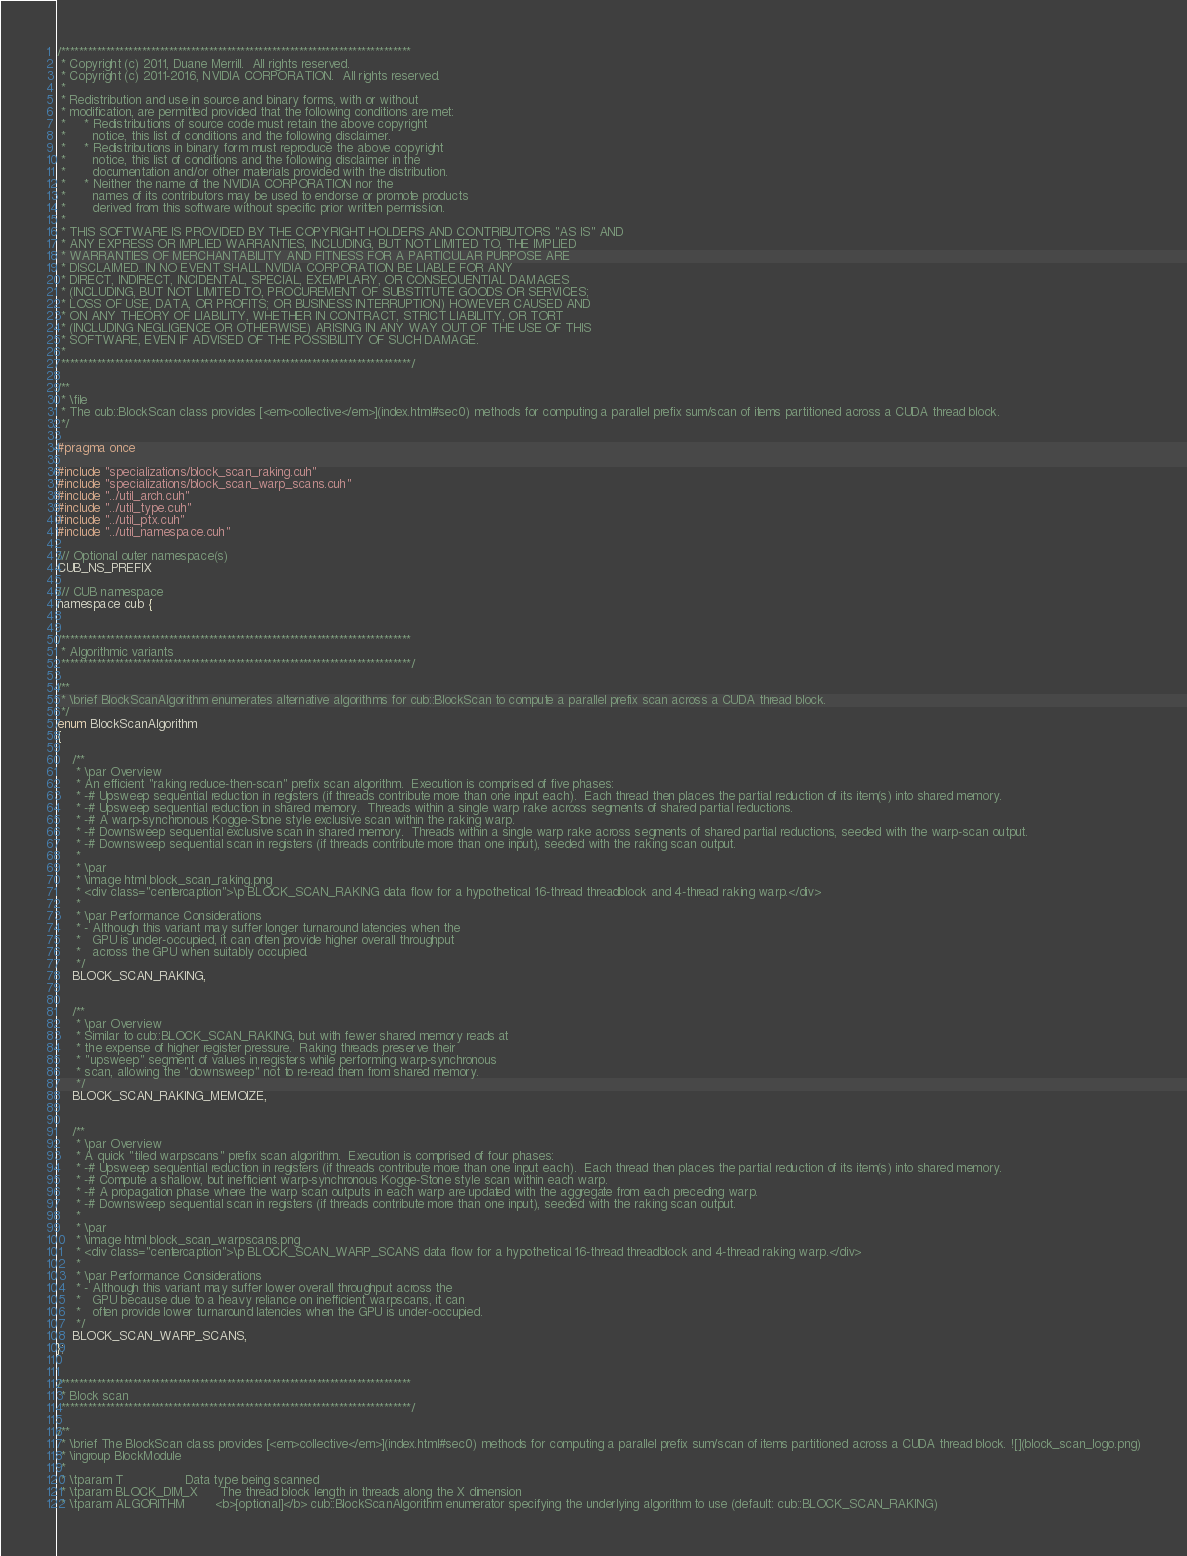Convert code to text. <code><loc_0><loc_0><loc_500><loc_500><_Cuda_>/******************************************************************************
 * Copyright (c) 2011, Duane Merrill.  All rights reserved.
 * Copyright (c) 2011-2016, NVIDIA CORPORATION.  All rights reserved.
 *
 * Redistribution and use in source and binary forms, with or without
 * modification, are permitted provided that the following conditions are met:
 *     * Redistributions of source code must retain the above copyright
 *       notice, this list of conditions and the following disclaimer.
 *     * Redistributions in binary form must reproduce the above copyright
 *       notice, this list of conditions and the following disclaimer in the
 *       documentation and/or other materials provided with the distribution.
 *     * Neither the name of the NVIDIA CORPORATION nor the
 *       names of its contributors may be used to endorse or promote products
 *       derived from this software without specific prior written permission.
 *
 * THIS SOFTWARE IS PROVIDED BY THE COPYRIGHT HOLDERS AND CONTRIBUTORS "AS IS" AND
 * ANY EXPRESS OR IMPLIED WARRANTIES, INCLUDING, BUT NOT LIMITED TO, THE IMPLIED
 * WARRANTIES OF MERCHANTABILITY AND FITNESS FOR A PARTICULAR PURPOSE ARE
 * DISCLAIMED. IN NO EVENT SHALL NVIDIA CORPORATION BE LIABLE FOR ANY
 * DIRECT, INDIRECT, INCIDENTAL, SPECIAL, EXEMPLARY, OR CONSEQUENTIAL DAMAGES
 * (INCLUDING, BUT NOT LIMITED TO, PROCUREMENT OF SUBSTITUTE GOODS OR SERVICES;
 * LOSS OF USE, DATA, OR PROFITS; OR BUSINESS INTERRUPTION) HOWEVER CAUSED AND
 * ON ANY THEORY OF LIABILITY, WHETHER IN CONTRACT, STRICT LIABILITY, OR TORT
 * (INCLUDING NEGLIGENCE OR OTHERWISE) ARISING IN ANY WAY OUT OF THE USE OF THIS
 * SOFTWARE, EVEN IF ADVISED OF THE POSSIBILITY OF SUCH DAMAGE.
 *
 ******************************************************************************/

/**
 * \file
 * The cub::BlockScan class provides [<em>collective</em>](index.html#sec0) methods for computing a parallel prefix sum/scan of items partitioned across a CUDA thread block.
 */

#pragma once

#include "specializations/block_scan_raking.cuh"
#include "specializations/block_scan_warp_scans.cuh"
#include "../util_arch.cuh"
#include "../util_type.cuh"
#include "../util_ptx.cuh"
#include "../util_namespace.cuh"

/// Optional outer namespace(s)
CUB_NS_PREFIX

/// CUB namespace
namespace cub {


/******************************************************************************
 * Algorithmic variants
 ******************************************************************************/

/**
 * \brief BlockScanAlgorithm enumerates alternative algorithms for cub::BlockScan to compute a parallel prefix scan across a CUDA thread block.
 */
enum BlockScanAlgorithm
{

    /**
     * \par Overview
     * An efficient "raking reduce-then-scan" prefix scan algorithm.  Execution is comprised of five phases:
     * -# Upsweep sequential reduction in registers (if threads contribute more than one input each).  Each thread then places the partial reduction of its item(s) into shared memory.
     * -# Upsweep sequential reduction in shared memory.  Threads within a single warp rake across segments of shared partial reductions.
     * -# A warp-synchronous Kogge-Stone style exclusive scan within the raking warp.
     * -# Downsweep sequential exclusive scan in shared memory.  Threads within a single warp rake across segments of shared partial reductions, seeded with the warp-scan output.
     * -# Downsweep sequential scan in registers (if threads contribute more than one input), seeded with the raking scan output.
     *
     * \par
     * \image html block_scan_raking.png
     * <div class="centercaption">\p BLOCK_SCAN_RAKING data flow for a hypothetical 16-thread threadblock and 4-thread raking warp.</div>
     *
     * \par Performance Considerations
     * - Although this variant may suffer longer turnaround latencies when the
     *   GPU is under-occupied, it can often provide higher overall throughput
     *   across the GPU when suitably occupied.
     */
    BLOCK_SCAN_RAKING,


    /**
     * \par Overview
     * Similar to cub::BLOCK_SCAN_RAKING, but with fewer shared memory reads at
     * the expense of higher register pressure.  Raking threads preserve their
     * "upsweep" segment of values in registers while performing warp-synchronous
     * scan, allowing the "downsweep" not to re-read them from shared memory.
     */
    BLOCK_SCAN_RAKING_MEMOIZE,


    /**
     * \par Overview
     * A quick "tiled warpscans" prefix scan algorithm.  Execution is comprised of four phases:
     * -# Upsweep sequential reduction in registers (if threads contribute more than one input each).  Each thread then places the partial reduction of its item(s) into shared memory.
     * -# Compute a shallow, but inefficient warp-synchronous Kogge-Stone style scan within each warp.
     * -# A propagation phase where the warp scan outputs in each warp are updated with the aggregate from each preceding warp.
     * -# Downsweep sequential scan in registers (if threads contribute more than one input), seeded with the raking scan output.
     *
     * \par
     * \image html block_scan_warpscans.png
     * <div class="centercaption">\p BLOCK_SCAN_WARP_SCANS data flow for a hypothetical 16-thread threadblock and 4-thread raking warp.</div>
     *
     * \par Performance Considerations
     * - Although this variant may suffer lower overall throughput across the
     *   GPU because due to a heavy reliance on inefficient warpscans, it can
     *   often provide lower turnaround latencies when the GPU is under-occupied.
     */
    BLOCK_SCAN_WARP_SCANS,
};


/******************************************************************************
 * Block scan
 ******************************************************************************/

/**
 * \brief The BlockScan class provides [<em>collective</em>](index.html#sec0) methods for computing a parallel prefix sum/scan of items partitioned across a CUDA thread block. ![](block_scan_logo.png)
 * \ingroup BlockModule
 *
 * \tparam T                Data type being scanned
 * \tparam BLOCK_DIM_X      The thread block length in threads along the X dimension
 * \tparam ALGORITHM        <b>[optional]</b> cub::BlockScanAlgorithm enumerator specifying the underlying algorithm to use (default: cub::BLOCK_SCAN_RAKING)</code> 